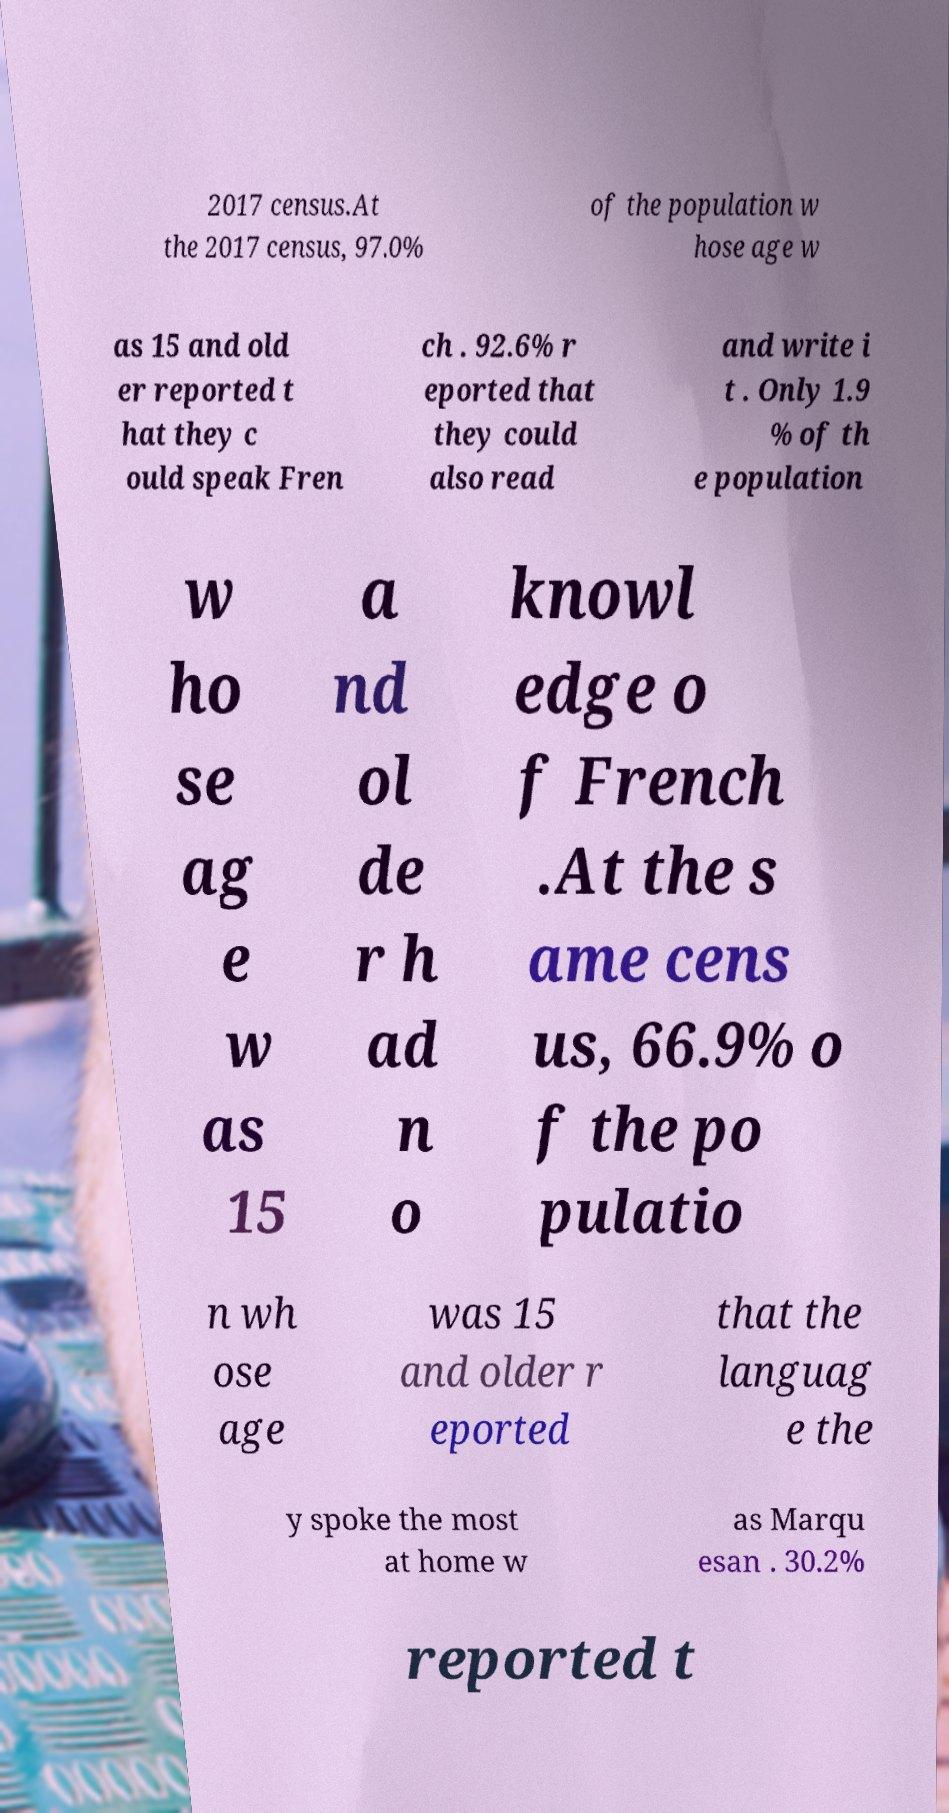Can you read and provide the text displayed in the image?This photo seems to have some interesting text. Can you extract and type it out for me? 2017 census.At the 2017 census, 97.0% of the population w hose age w as 15 and old er reported t hat they c ould speak Fren ch . 92.6% r eported that they could also read and write i t . Only 1.9 % of th e population w ho se ag e w as 15 a nd ol de r h ad n o knowl edge o f French .At the s ame cens us, 66.9% o f the po pulatio n wh ose age was 15 and older r eported that the languag e the y spoke the most at home w as Marqu esan . 30.2% reported t 